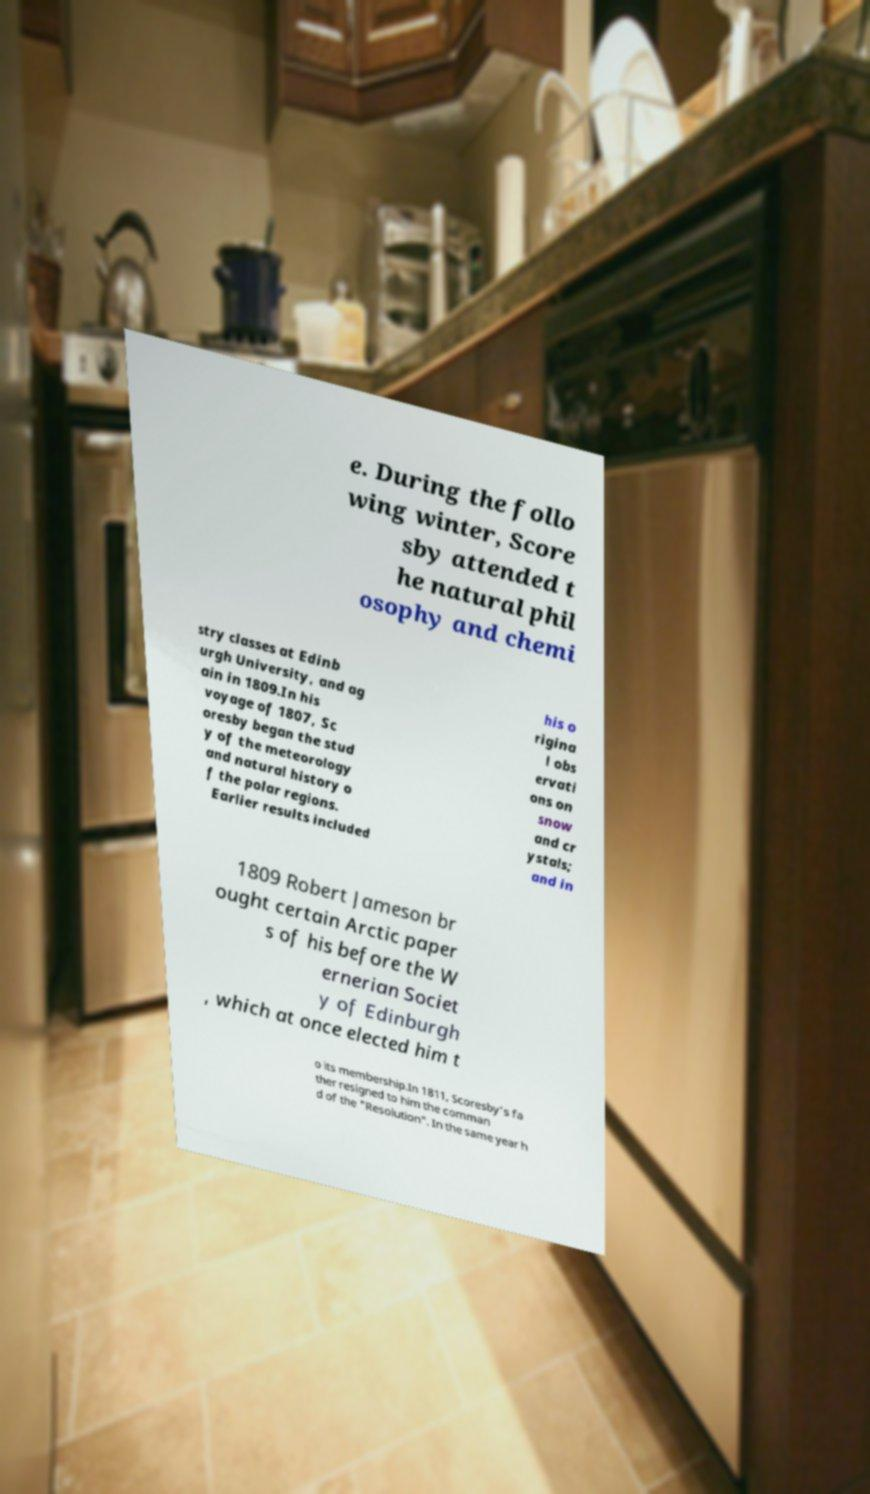Can you read and provide the text displayed in the image?This photo seems to have some interesting text. Can you extract and type it out for me? e. During the follo wing winter, Score sby attended t he natural phil osophy and chemi stry classes at Edinb urgh University, and ag ain in 1809.In his voyage of 1807, Sc oresby began the stud y of the meteorology and natural history o f the polar regions. Earlier results included his o rigina l obs ervati ons on snow and cr ystals; and in 1809 Robert Jameson br ought certain Arctic paper s of his before the W ernerian Societ y of Edinburgh , which at once elected him t o its membership.In 1811, Scoresby's fa ther resigned to him the comman d of the "Resolution". In the same year h 